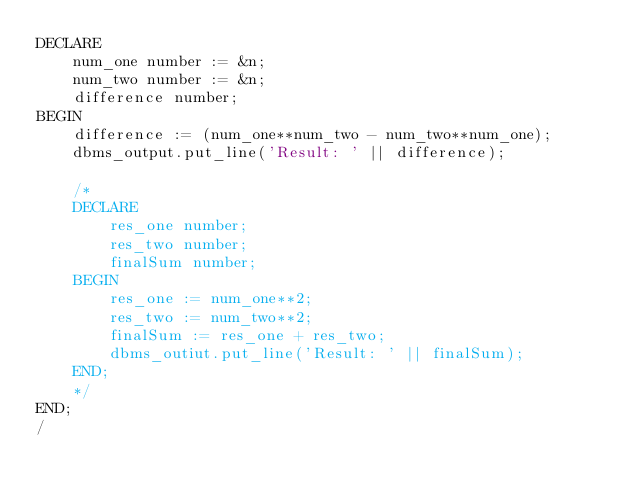<code> <loc_0><loc_0><loc_500><loc_500><_SQL_>DECLARE
	num_one number := &n;
	num_two number := &n;
	difference number;
BEGIN
	difference := (num_one**num_two - num_two**num_one);
	dbms_output.put_line('Result: ' || difference);

	/*
	DECLARE
		res_one number;
		res_two number;
		finalSum number;
	BEGIN
		res_one := num_one**2;
		res_two := num_two**2;
		finalSum := res_one + res_two;
		dbms_outiut.put_line('Result: ' || finalSum);
	END;
 	*/
END;
/

</code> 